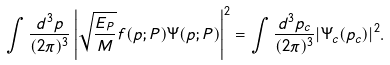Convert formula to latex. <formula><loc_0><loc_0><loc_500><loc_500>\int \frac { d ^ { 3 } p } { ( 2 \pi ) ^ { 3 } } \left | \sqrt { \frac { E _ { P } } { M } } f ( { p } ; { P } ) \Psi ( { p } ; { P } ) \right | ^ { 2 } = \int \frac { d ^ { 3 } p _ { c } } { ( 2 \pi ) ^ { 3 } } | \Psi _ { c } ( { p } _ { c } ) | ^ { 2 } .</formula> 